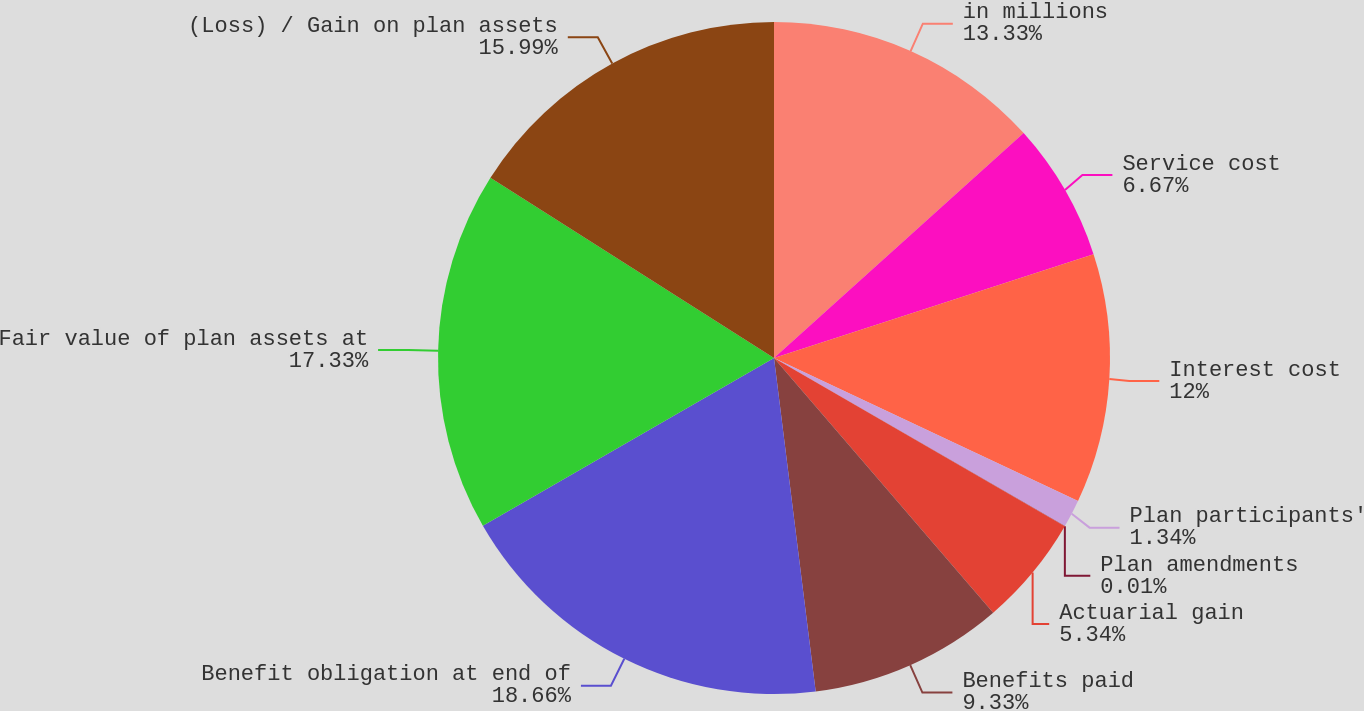<chart> <loc_0><loc_0><loc_500><loc_500><pie_chart><fcel>in millions<fcel>Service cost<fcel>Interest cost<fcel>Plan participants'<fcel>Plan amendments<fcel>Actuarial gain<fcel>Benefits paid<fcel>Benefit obligation at end of<fcel>Fair value of plan assets at<fcel>(Loss) / Gain on plan assets<nl><fcel>13.33%<fcel>6.67%<fcel>12.0%<fcel>1.34%<fcel>0.01%<fcel>5.34%<fcel>9.33%<fcel>18.66%<fcel>17.33%<fcel>15.99%<nl></chart> 